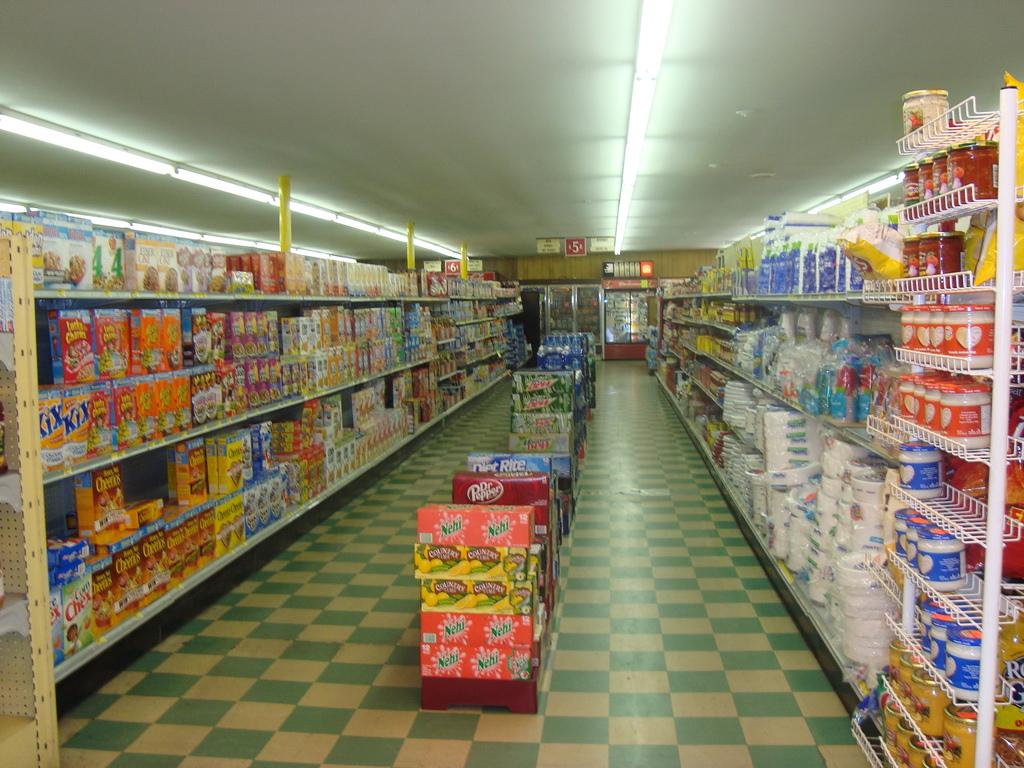What is the first cereal on the middle shelf?
Provide a short and direct response. Kix. 